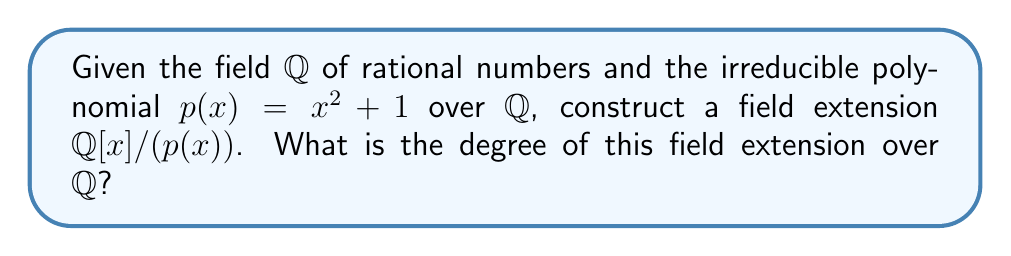Provide a solution to this math problem. To construct a field extension using an irreducible polynomial over a base field, we follow these steps:

1. Start with the base field $\mathbb{Q}$.

2. Consider the polynomial ring $\mathbb{Q}[x]$ over $\mathbb{Q}$.

3. Take the irreducible polynomial $p(x) = x^2 + 1$.

4. Form the quotient ring $\mathbb{Q}[x]/(p(x))$, where $(p(x))$ is the ideal generated by $p(x)$.

5. Since $p(x)$ is irreducible over $\mathbb{Q}$, the quotient ring $\mathbb{Q}[x]/(p(x))$ is a field.

6. This field $\mathbb{Q}[x]/(p(x))$ is our desired field extension.

To find the degree of the field extension:

7. The degree of a field extension is equal to the degree of the irreducible polynomial used to construct it.

8. The degree of $p(x) = x^2 + 1$ is 2.

Therefore, the degree of the field extension $\mathbb{Q}[x]/(p(x))$ over $\mathbb{Q}$ is 2.

Note: This field extension is isomorphic to $\mathbb{Q}(i)$, the field of complex numbers with rational real and imaginary parts.
Answer: 2 